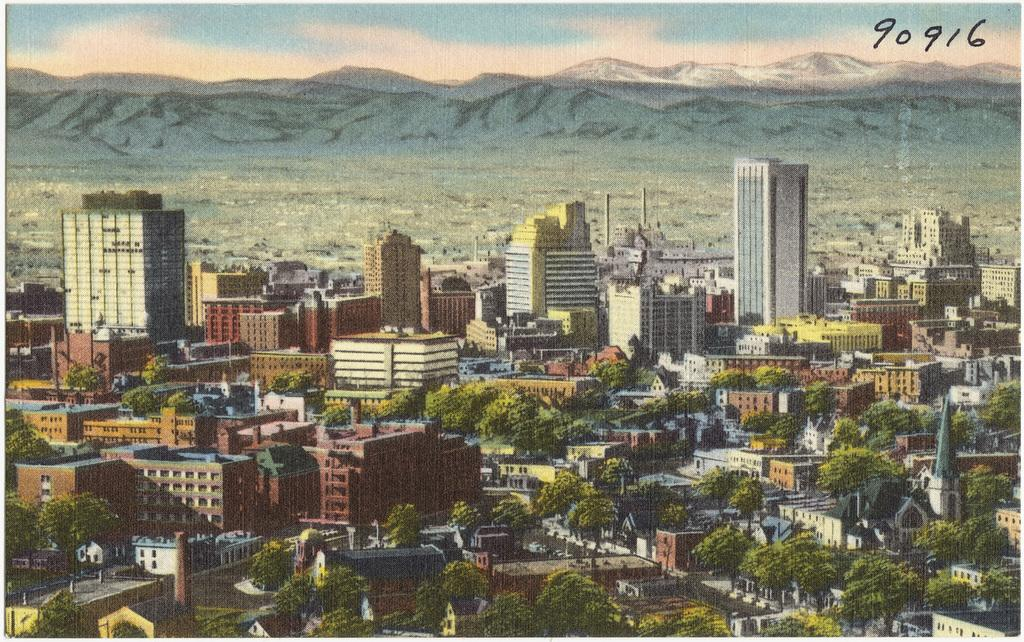What types of structures are present in the image? There are multiple buildings in the image. What other natural elements can be seen in the image? There are trees in the image. What can be seen in the distance in the image? There are mountains visible in the background of the image. What type of metal is used to make the pin visible in the image? There is no pin present in the image, so it is not possible to determine what type of metal might be used to make it. 